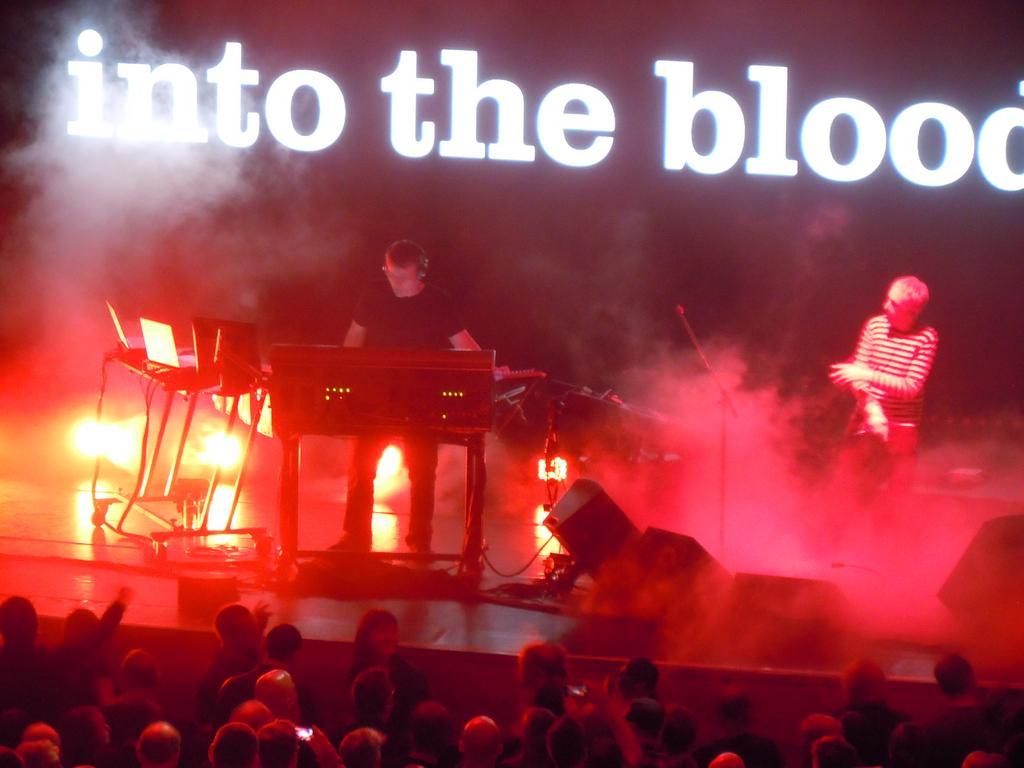In one or two sentences, can you explain what this image depicts? In the picture I can see group of persons standing on ground, in the background of the picture I can see two persons standing on stage playing musical instruments, there are laptops, some other objects on table, there are some words displaying. 